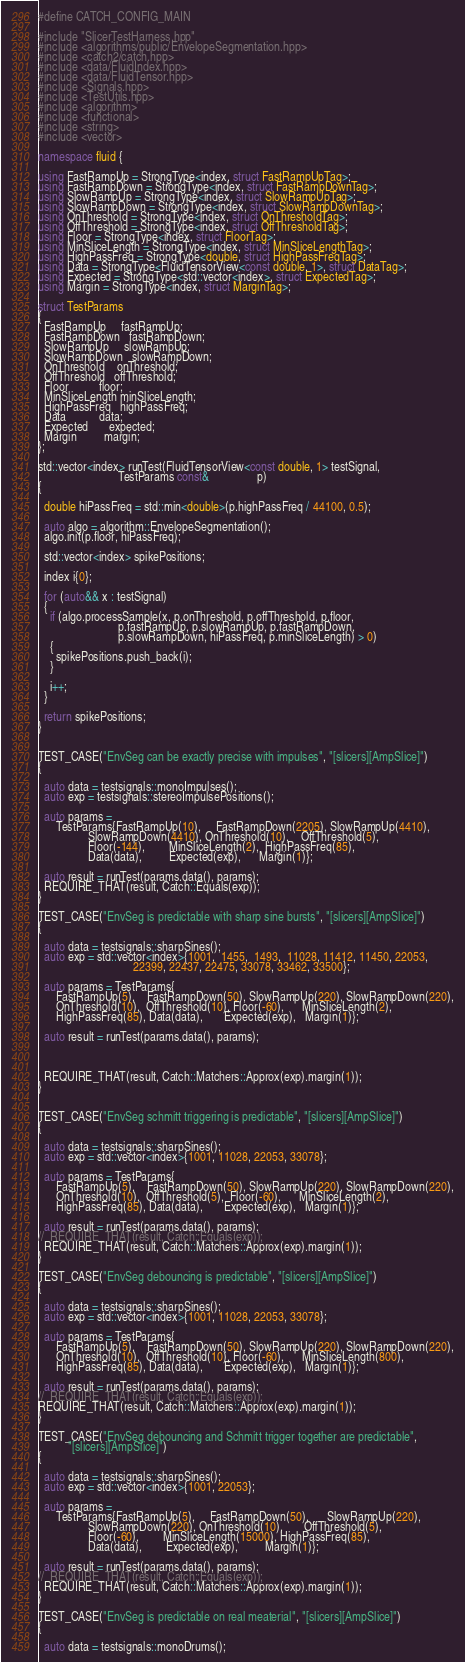<code> <loc_0><loc_0><loc_500><loc_500><_C++_>#define CATCH_CONFIG_MAIN

#include "SlicerTestHarness.hpp"
#include <algorithms/public/EnvelopeSegmentation.hpp>
#include <catch2/catch.hpp>
#include <data/FluidIndex.hpp>
#include <data/FluidTensor.hpp>
#include <Signals.hpp>
#include <TestUtils.hpp>
#include <algorithm>
#include <functional>
#include <string>
#include <vector>

namespace fluid {

using FastRampUp = StrongType<index, struct FastRampUpTag>;
using FastRampDown = StrongType<index, struct FastRampDownTag>;
using SlowRampUp = StrongType<index, struct SlowRampUpTag>;
using SlowRampDown = StrongType<index, struct SlowRampDownTag>;
using OnThreshold = StrongType<index, struct OnThresholdTag>;
using OffThreshold = StrongType<index, struct OffThresholdTag>;
using Floor = StrongType<index, struct FloorTag>;
using MinSliceLength = StrongType<index, struct MinSliceLengthTag>;
using HighPassFreq = StrongType<double, struct HighPassFreqTag>;
using Data = StrongType<FluidTensorView<const double, 1>, struct DataTag>;
using Expected = StrongType<std::vector<index>, struct ExpectedTag>;
using Margin = StrongType<index, struct MarginTag>;

struct TestParams
{
  FastRampUp     fastRampUp;
  FastRampDown   fastRampDown;
  SlowRampUp     slowRampUp;
  SlowRampDown   slowRampDown;
  OnThreshold    onThreshold;
  OffThreshold   offThreshold;
  Floor          floor;
  MinSliceLength minSliceLength;
  HighPassFreq   highPassFreq;
  Data           data;
  Expected       expected;
  Margin         margin;
};

std::vector<index> runTest(FluidTensorView<const double, 1> testSignal,
                           TestParams const&                p)
{

  double hiPassFreq = std::min<double>(p.highPassFreq / 44100, 0.5);

  auto algo = algorithm::EnvelopeSegmentation();
  algo.init(p.floor, hiPassFreq);

  std::vector<index> spikePositions;

  index i{0};

  for (auto&& x : testSignal)
  {
    if (algo.processSample(x, p.onThreshold, p.offThreshold, p.floor,
                           p.fastRampUp, p.slowRampUp, p.fastRampDown,
                           p.slowRampDown, hiPassFreq, p.minSliceLength) > 0)
    {
      spikePositions.push_back(i);
    }

    i++;
  }

  return spikePositions;
}


TEST_CASE("EnvSeg can be exactly precise with impulses", "[slicers][AmpSlice]")
{

  auto data = testsignals::monoImpulses();
  auto exp = testsignals::stereoImpulsePositions();

  auto params =
      TestParams{FastRampUp(10),     FastRampDown(2205), SlowRampUp(4410),
                 SlowRampDown(4410), OnThreshold(10),    OffThreshold(5),
                 Floor(-144),        MinSliceLength(2),  HighPassFreq(85),
                 Data(data),         Expected(exp),      Margin(1)};

  auto result = runTest(params.data(), params);
  REQUIRE_THAT(result, Catch::Equals(exp));
}

TEST_CASE("EnvSeg is predictable with sharp sine bursts", "[slicers][AmpSlice]")
{

  auto data = testsignals::sharpSines();
  auto exp = std::vector<index>{1001,  1455,  1493,  11028, 11412, 11450, 22053,
                                22399, 22437, 22475, 33078, 33462, 33500};

  auto params = TestParams{
      FastRampUp(5),    FastRampDown(50), SlowRampUp(220), SlowRampDown(220),
      OnThreshold(10),  OffThreshold(10), Floor(-60),      MinSliceLength(2),
      HighPassFreq(85), Data(data),       Expected(exp),   Margin(1)};

  auto result = runTest(params.data(), params);
  
  
  
  REQUIRE_THAT(result, Catch::Matchers::Approx(exp).margin(1));
}


TEST_CASE("EnvSeg schmitt triggering is predictable", "[slicers][AmpSlice]")
{

  auto data = testsignals::sharpSines();
  auto exp = std::vector<index>{1001, 11028, 22053, 33078};

  auto params = TestParams{
      FastRampUp(5),    FastRampDown(50), SlowRampUp(220), SlowRampDown(220),
      OnThreshold(10),  OffThreshold(5),  Floor(-60),      MinSliceLength(2),
      HighPassFreq(85), Data(data),       Expected(exp),   Margin(1)};

  auto result = runTest(params.data(), params);
//  REQUIRE_THAT(result, Catch::Equals(exp));
  REQUIRE_THAT(result, Catch::Matchers::Approx(exp).margin(1));
}

TEST_CASE("EnvSeg debouncing is predictable", "[slicers][AmpSlice]")
{

  auto data = testsignals::sharpSines();
  auto exp = std::vector<index>{1001, 11028, 22053, 33078};

  auto params = TestParams{
      FastRampUp(5),    FastRampDown(50), SlowRampUp(220), SlowRampDown(220),
      OnThreshold(10),  OffThreshold(10), Floor(-60),      MinSliceLength(800),
      HighPassFreq(85), Data(data),       Expected(exp),   Margin(1)};

  auto result = runTest(params.data(), params);
//  REQUIRE_THAT(result, Catch::Equals(exp));
REQUIRE_THAT(result, Catch::Matchers::Approx(exp).margin(1));
}

TEST_CASE("EnvSeg debouncing and Schmitt trigger together are predictable",
          "[slicers][AmpSlice]")
{

  auto data = testsignals::sharpSines();
  auto exp = std::vector<index>{1001, 22053};

  auto params =
      TestParams{FastRampUp(5),     FastRampDown(50),      SlowRampUp(220),
                 SlowRampDown(220), OnThreshold(10),       OffThreshold(5),
                 Floor(-60),        MinSliceLength(15000), HighPassFreq(85),
                 Data(data),        Expected(exp),         Margin(1)};

  auto result = runTest(params.data(), params);
//  REQUIRE_THAT(result, Catch::Equals(exp));
  REQUIRE_THAT(result, Catch::Matchers::Approx(exp).margin(1));
}

TEST_CASE("EnvSeg is predictable on real meaterial", "[slicers][AmpSlice]")
{

  auto data = testsignals::monoDrums();</code> 